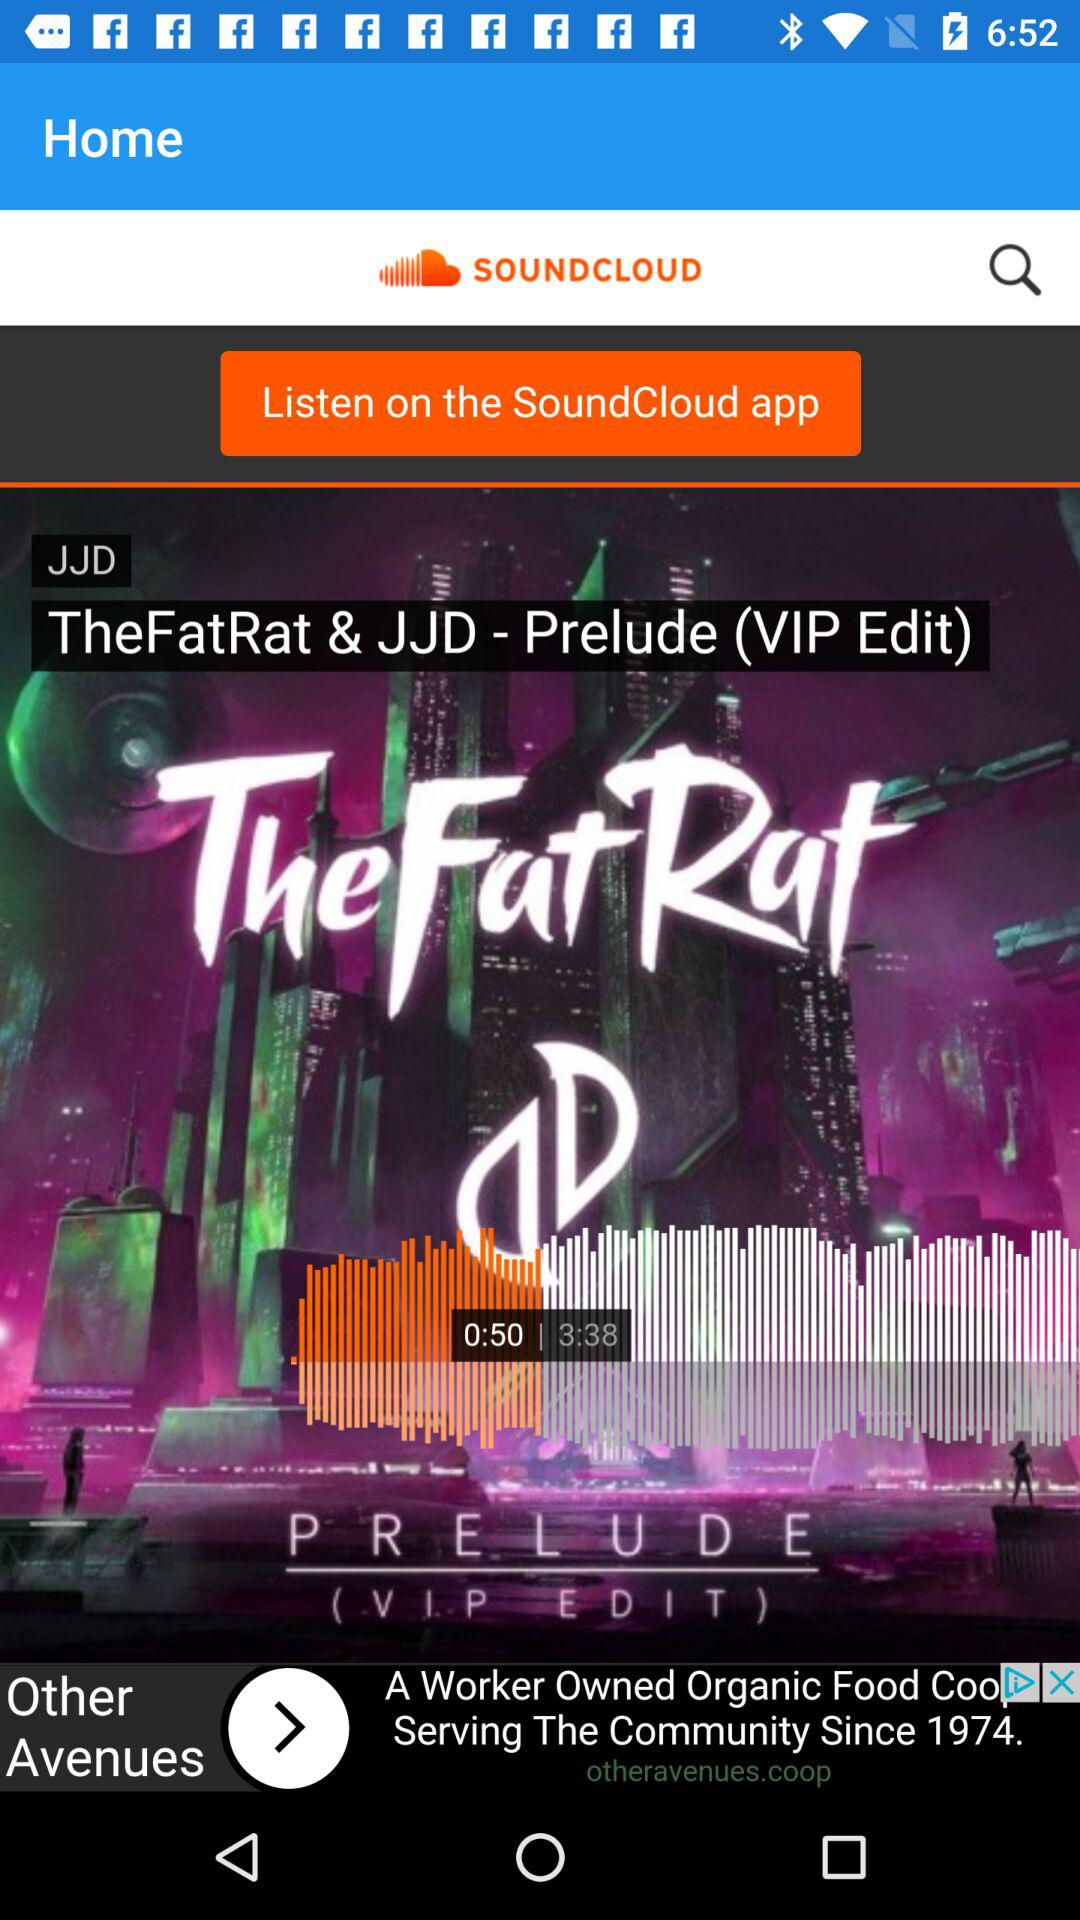What is the duration of the audio "TheFatRat & JJD - Prelude (VIP Edit)? The duration is 3:38. 